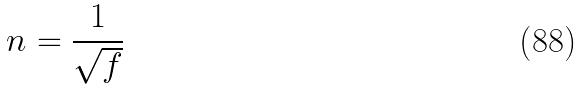<formula> <loc_0><loc_0><loc_500><loc_500>n = \frac { 1 } { \sqrt { f } }</formula> 